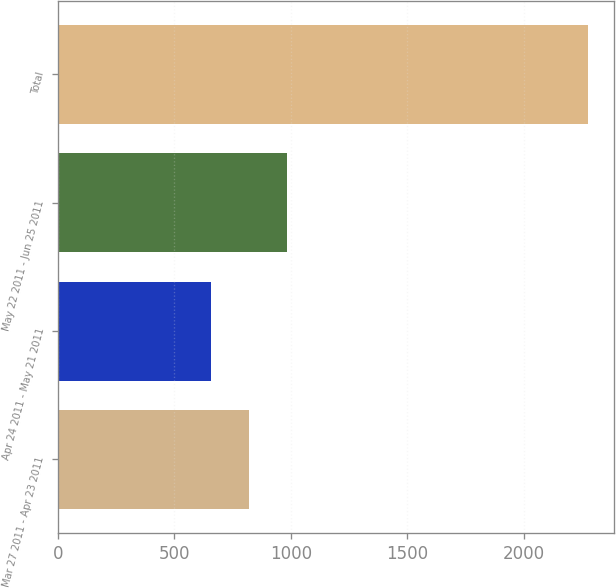Convert chart. <chart><loc_0><loc_0><loc_500><loc_500><bar_chart><fcel>Mar 27 2011 - Apr 23 2011<fcel>Apr 24 2011 - May 21 2011<fcel>May 22 2011 - Jun 25 2011<fcel>Total<nl><fcel>821.5<fcel>660<fcel>983<fcel>2275<nl></chart> 